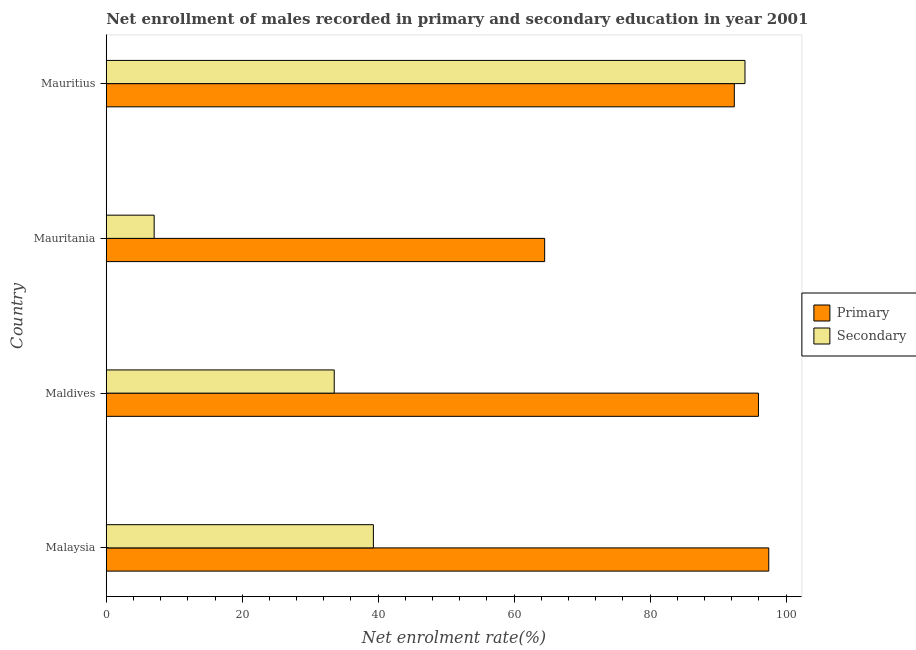How many different coloured bars are there?
Make the answer very short. 2. Are the number of bars on each tick of the Y-axis equal?
Offer a terse response. Yes. What is the label of the 4th group of bars from the top?
Provide a succinct answer. Malaysia. What is the enrollment rate in primary education in Mauritius?
Keep it short and to the point. 92.4. Across all countries, what is the maximum enrollment rate in secondary education?
Give a very brief answer. 93.97. Across all countries, what is the minimum enrollment rate in primary education?
Provide a succinct answer. 64.5. In which country was the enrollment rate in primary education maximum?
Make the answer very short. Malaysia. In which country was the enrollment rate in secondary education minimum?
Provide a succinct answer. Mauritania. What is the total enrollment rate in secondary education in the graph?
Give a very brief answer. 173.86. What is the difference between the enrollment rate in primary education in Maldives and that in Mauritius?
Provide a succinct answer. 3.55. What is the difference between the enrollment rate in secondary education in Malaysia and the enrollment rate in primary education in Mauritius?
Your response must be concise. -53.1. What is the average enrollment rate in primary education per country?
Provide a succinct answer. 87.58. What is the difference between the enrollment rate in secondary education and enrollment rate in primary education in Mauritius?
Offer a terse response. 1.57. What is the ratio of the enrollment rate in primary education in Maldives to that in Mauritania?
Provide a succinct answer. 1.49. What is the difference between the highest and the second highest enrollment rate in primary education?
Keep it short and to the point. 1.51. What is the difference between the highest and the lowest enrollment rate in primary education?
Make the answer very short. 32.97. Is the sum of the enrollment rate in primary education in Malaysia and Mauritania greater than the maximum enrollment rate in secondary education across all countries?
Offer a very short reply. Yes. What does the 1st bar from the top in Maldives represents?
Your answer should be very brief. Secondary. What does the 2nd bar from the bottom in Malaysia represents?
Offer a very short reply. Secondary. What is the difference between two consecutive major ticks on the X-axis?
Offer a terse response. 20. Are the values on the major ticks of X-axis written in scientific E-notation?
Your answer should be compact. No. How are the legend labels stacked?
Give a very brief answer. Vertical. What is the title of the graph?
Offer a very short reply. Net enrollment of males recorded in primary and secondary education in year 2001. Does "Male" appear as one of the legend labels in the graph?
Offer a very short reply. No. What is the label or title of the X-axis?
Your answer should be compact. Net enrolment rate(%). What is the label or title of the Y-axis?
Your response must be concise. Country. What is the Net enrolment rate(%) in Primary in Malaysia?
Offer a terse response. 97.46. What is the Net enrolment rate(%) in Secondary in Malaysia?
Your answer should be compact. 39.3. What is the Net enrolment rate(%) in Primary in Maldives?
Make the answer very short. 95.95. What is the Net enrolment rate(%) in Secondary in Maldives?
Your response must be concise. 33.54. What is the Net enrolment rate(%) of Primary in Mauritania?
Offer a very short reply. 64.5. What is the Net enrolment rate(%) of Secondary in Mauritania?
Your answer should be very brief. 7.05. What is the Net enrolment rate(%) in Primary in Mauritius?
Keep it short and to the point. 92.4. What is the Net enrolment rate(%) in Secondary in Mauritius?
Your answer should be very brief. 93.97. Across all countries, what is the maximum Net enrolment rate(%) in Primary?
Your answer should be compact. 97.46. Across all countries, what is the maximum Net enrolment rate(%) of Secondary?
Your response must be concise. 93.97. Across all countries, what is the minimum Net enrolment rate(%) of Primary?
Keep it short and to the point. 64.5. Across all countries, what is the minimum Net enrolment rate(%) of Secondary?
Offer a very short reply. 7.05. What is the total Net enrolment rate(%) in Primary in the graph?
Make the answer very short. 350.3. What is the total Net enrolment rate(%) of Secondary in the graph?
Your answer should be very brief. 173.86. What is the difference between the Net enrolment rate(%) of Primary in Malaysia and that in Maldives?
Ensure brevity in your answer.  1.51. What is the difference between the Net enrolment rate(%) in Secondary in Malaysia and that in Maldives?
Provide a short and direct response. 5.76. What is the difference between the Net enrolment rate(%) of Primary in Malaysia and that in Mauritania?
Keep it short and to the point. 32.97. What is the difference between the Net enrolment rate(%) of Secondary in Malaysia and that in Mauritania?
Provide a succinct answer. 32.25. What is the difference between the Net enrolment rate(%) of Primary in Malaysia and that in Mauritius?
Your response must be concise. 5.06. What is the difference between the Net enrolment rate(%) of Secondary in Malaysia and that in Mauritius?
Your answer should be very brief. -54.67. What is the difference between the Net enrolment rate(%) in Primary in Maldives and that in Mauritania?
Your answer should be very brief. 31.45. What is the difference between the Net enrolment rate(%) in Secondary in Maldives and that in Mauritania?
Your answer should be compact. 26.49. What is the difference between the Net enrolment rate(%) in Primary in Maldives and that in Mauritius?
Offer a terse response. 3.55. What is the difference between the Net enrolment rate(%) in Secondary in Maldives and that in Mauritius?
Keep it short and to the point. -60.43. What is the difference between the Net enrolment rate(%) in Primary in Mauritania and that in Mauritius?
Make the answer very short. -27.9. What is the difference between the Net enrolment rate(%) in Secondary in Mauritania and that in Mauritius?
Keep it short and to the point. -86.92. What is the difference between the Net enrolment rate(%) in Primary in Malaysia and the Net enrolment rate(%) in Secondary in Maldives?
Provide a succinct answer. 63.92. What is the difference between the Net enrolment rate(%) in Primary in Malaysia and the Net enrolment rate(%) in Secondary in Mauritania?
Your response must be concise. 90.41. What is the difference between the Net enrolment rate(%) of Primary in Malaysia and the Net enrolment rate(%) of Secondary in Mauritius?
Your response must be concise. 3.49. What is the difference between the Net enrolment rate(%) in Primary in Maldives and the Net enrolment rate(%) in Secondary in Mauritania?
Offer a very short reply. 88.9. What is the difference between the Net enrolment rate(%) in Primary in Maldives and the Net enrolment rate(%) in Secondary in Mauritius?
Your response must be concise. 1.98. What is the difference between the Net enrolment rate(%) in Primary in Mauritania and the Net enrolment rate(%) in Secondary in Mauritius?
Ensure brevity in your answer.  -29.47. What is the average Net enrolment rate(%) in Primary per country?
Provide a succinct answer. 87.58. What is the average Net enrolment rate(%) in Secondary per country?
Your answer should be very brief. 43.46. What is the difference between the Net enrolment rate(%) in Primary and Net enrolment rate(%) in Secondary in Malaysia?
Your response must be concise. 58.16. What is the difference between the Net enrolment rate(%) of Primary and Net enrolment rate(%) of Secondary in Maldives?
Keep it short and to the point. 62.41. What is the difference between the Net enrolment rate(%) of Primary and Net enrolment rate(%) of Secondary in Mauritania?
Provide a short and direct response. 57.45. What is the difference between the Net enrolment rate(%) of Primary and Net enrolment rate(%) of Secondary in Mauritius?
Keep it short and to the point. -1.57. What is the ratio of the Net enrolment rate(%) in Primary in Malaysia to that in Maldives?
Your answer should be very brief. 1.02. What is the ratio of the Net enrolment rate(%) in Secondary in Malaysia to that in Maldives?
Your response must be concise. 1.17. What is the ratio of the Net enrolment rate(%) in Primary in Malaysia to that in Mauritania?
Provide a succinct answer. 1.51. What is the ratio of the Net enrolment rate(%) of Secondary in Malaysia to that in Mauritania?
Ensure brevity in your answer.  5.58. What is the ratio of the Net enrolment rate(%) in Primary in Malaysia to that in Mauritius?
Your answer should be very brief. 1.05. What is the ratio of the Net enrolment rate(%) in Secondary in Malaysia to that in Mauritius?
Your answer should be very brief. 0.42. What is the ratio of the Net enrolment rate(%) in Primary in Maldives to that in Mauritania?
Your answer should be very brief. 1.49. What is the ratio of the Net enrolment rate(%) in Secondary in Maldives to that in Mauritania?
Your answer should be compact. 4.76. What is the ratio of the Net enrolment rate(%) of Primary in Maldives to that in Mauritius?
Give a very brief answer. 1.04. What is the ratio of the Net enrolment rate(%) of Secondary in Maldives to that in Mauritius?
Give a very brief answer. 0.36. What is the ratio of the Net enrolment rate(%) of Primary in Mauritania to that in Mauritius?
Your answer should be very brief. 0.7. What is the ratio of the Net enrolment rate(%) of Secondary in Mauritania to that in Mauritius?
Offer a terse response. 0.07. What is the difference between the highest and the second highest Net enrolment rate(%) of Primary?
Make the answer very short. 1.51. What is the difference between the highest and the second highest Net enrolment rate(%) in Secondary?
Provide a succinct answer. 54.67. What is the difference between the highest and the lowest Net enrolment rate(%) in Primary?
Your response must be concise. 32.97. What is the difference between the highest and the lowest Net enrolment rate(%) of Secondary?
Provide a short and direct response. 86.92. 